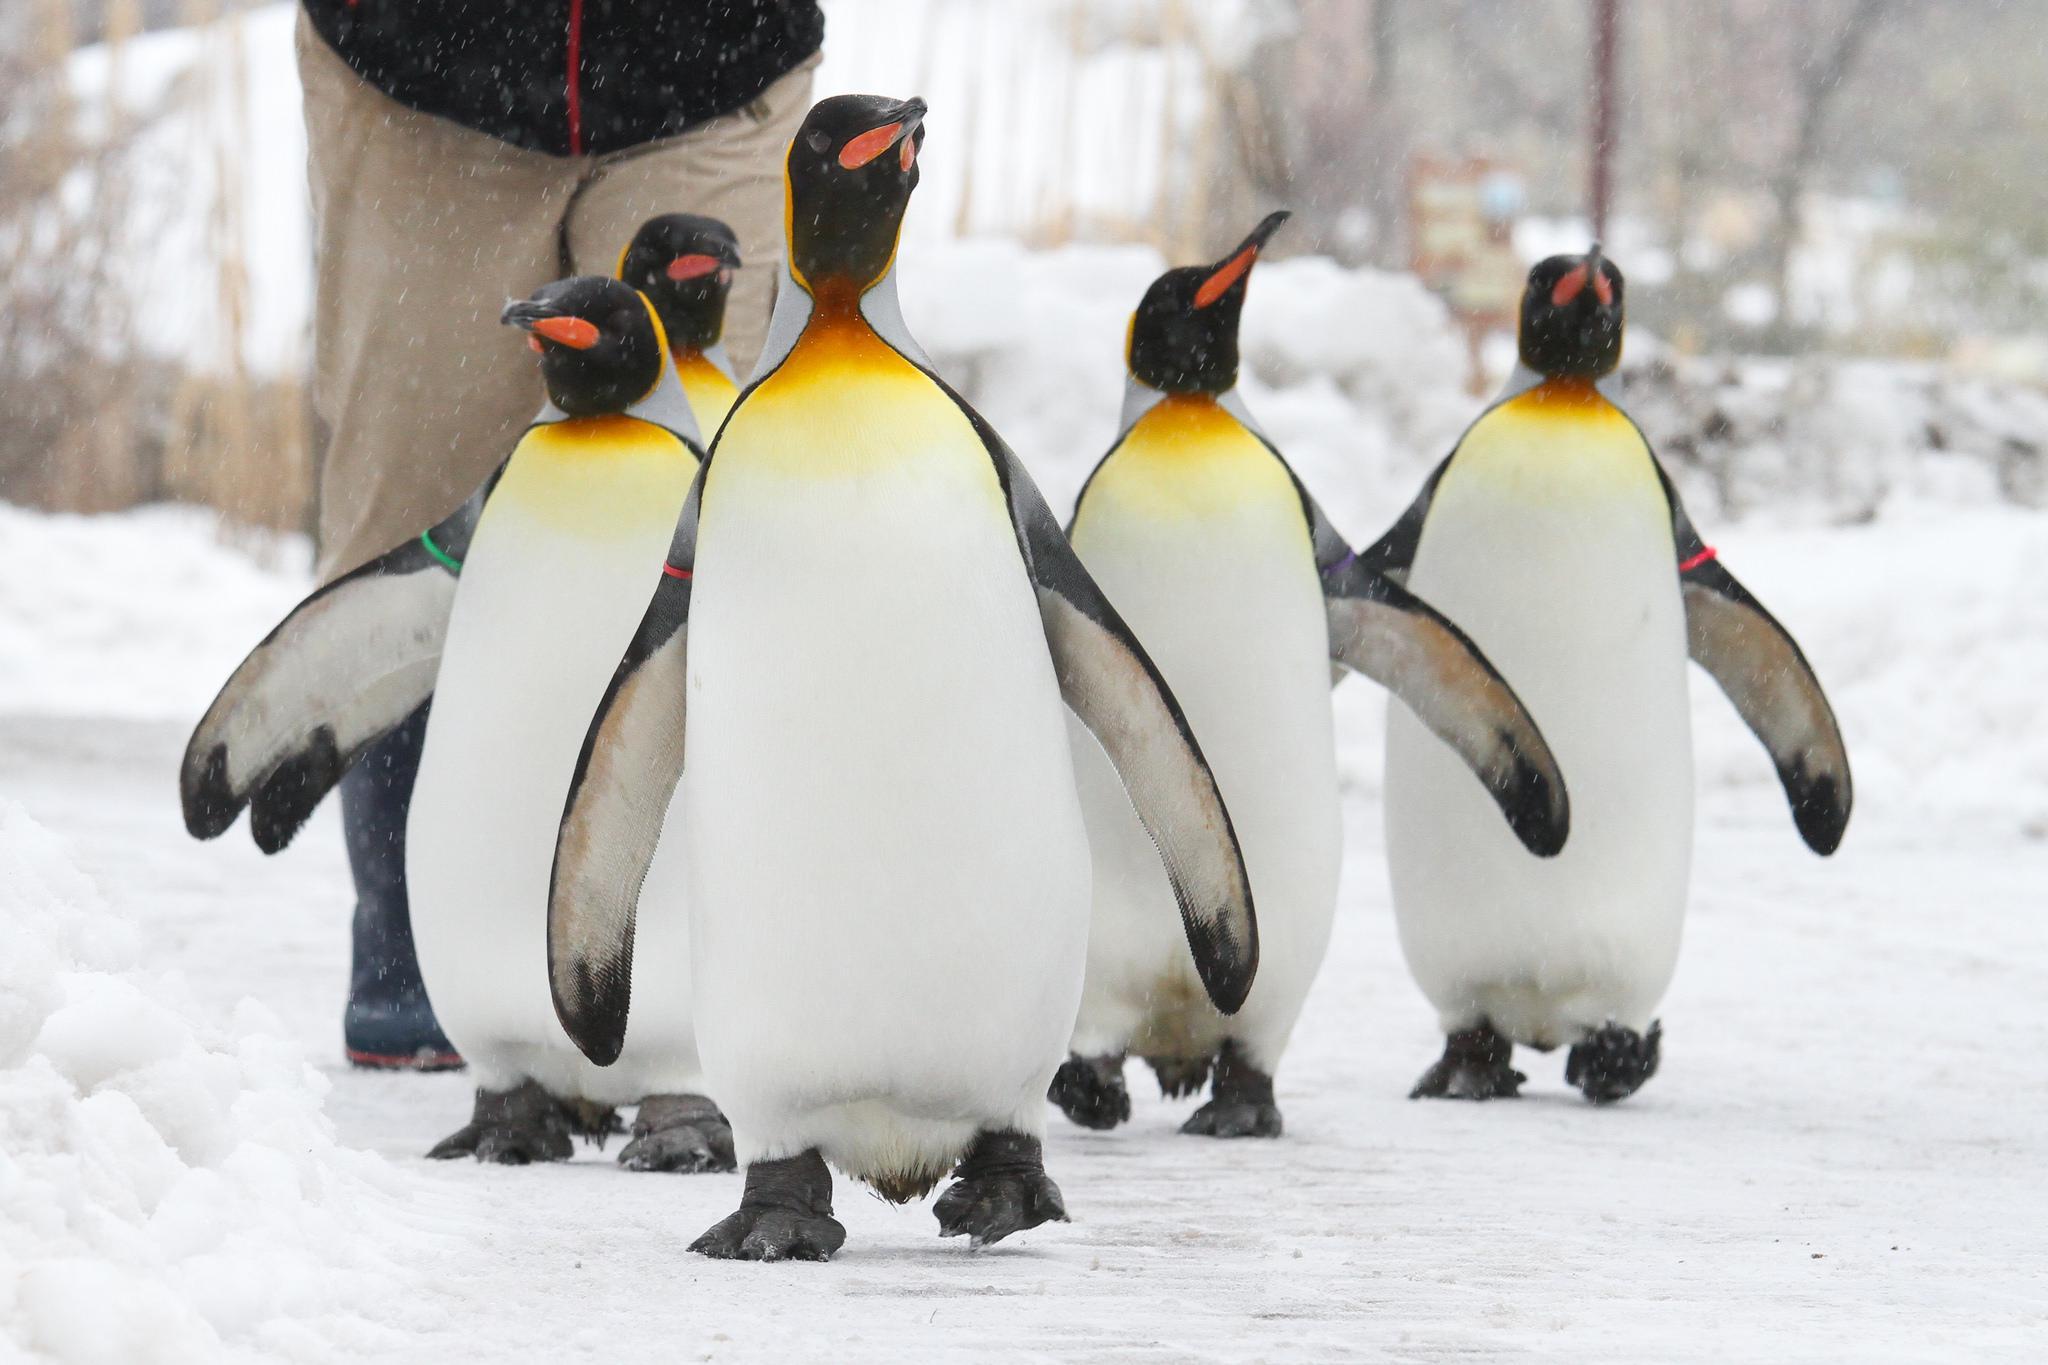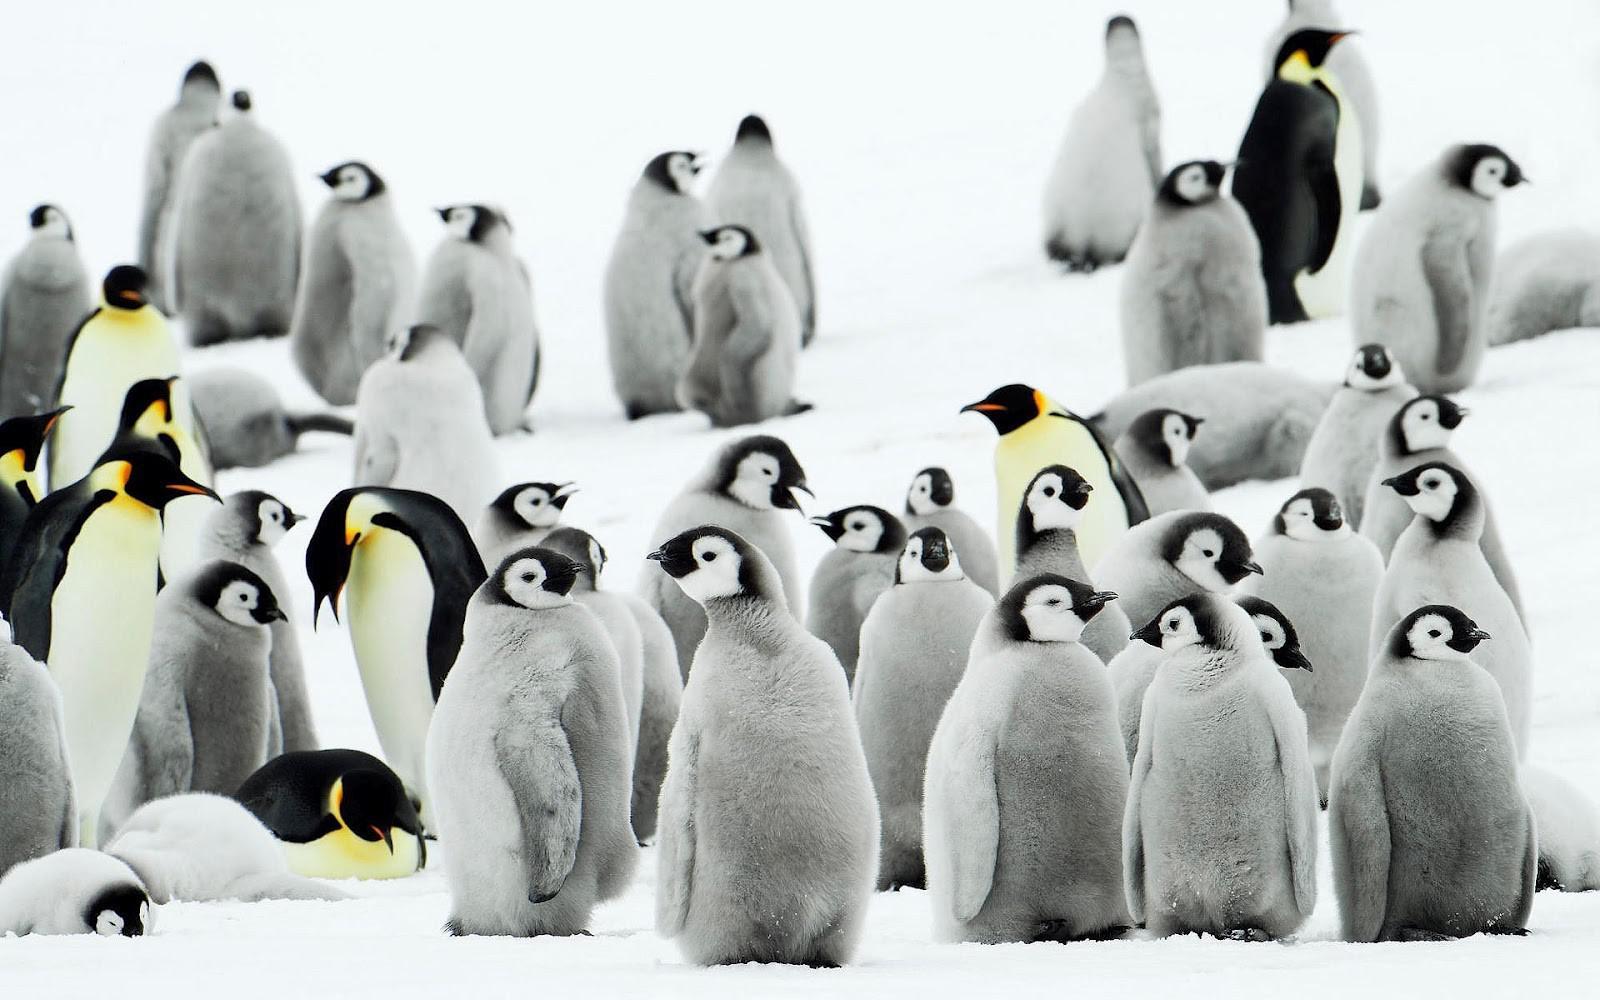The first image is the image on the left, the second image is the image on the right. For the images shown, is this caption "The penguins in at least one of the images are walking through the waves." true? Answer yes or no. No. The first image is the image on the left, the second image is the image on the right. Considering the images on both sides, is "Images include penguins walking through water." valid? Answer yes or no. No. 